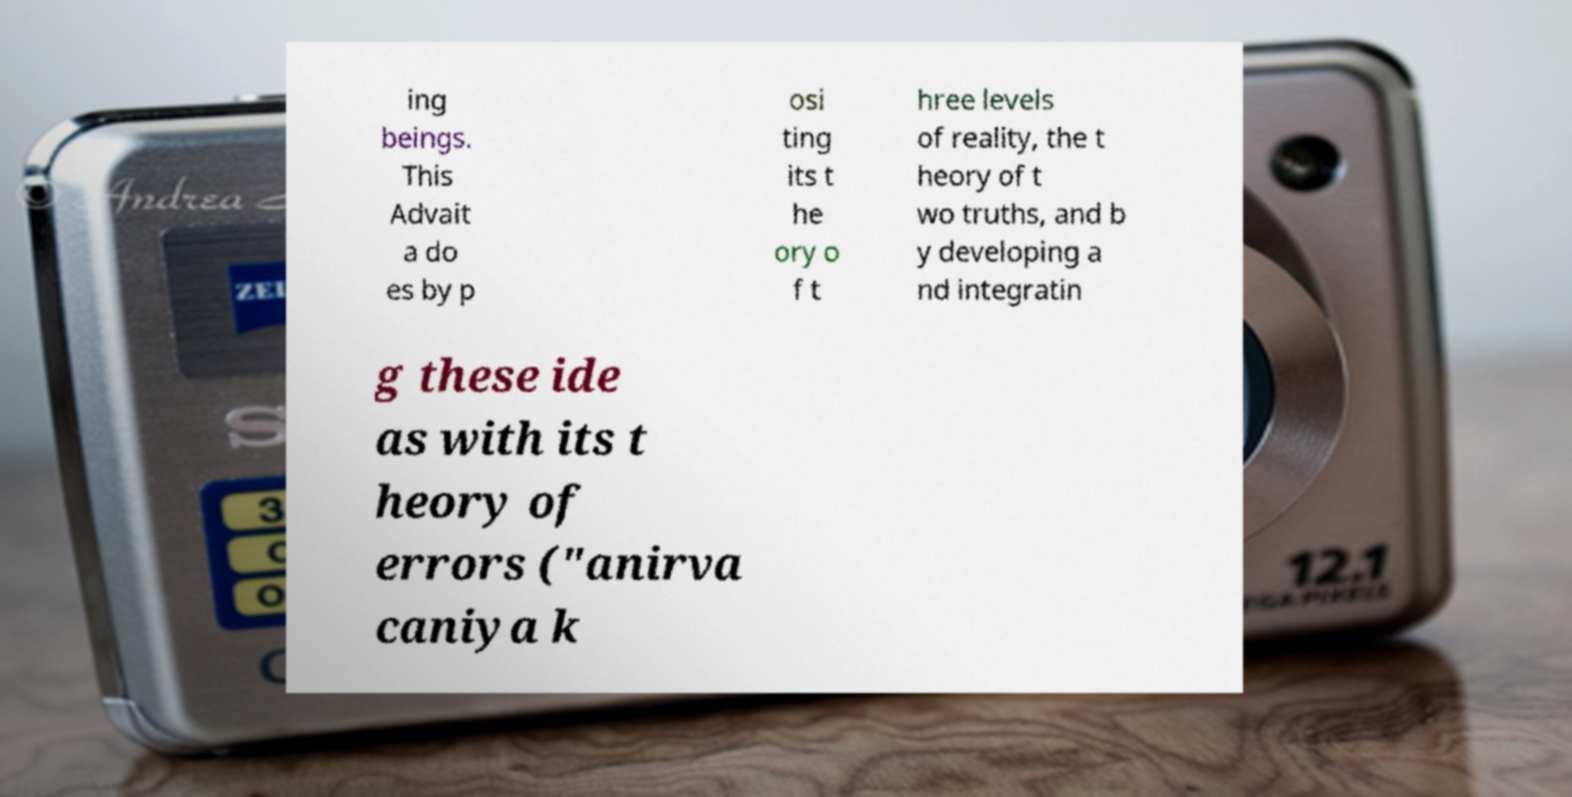Please read and relay the text visible in this image. What does it say? ing beings. This Advait a do es by p osi ting its t he ory o f t hree levels of reality, the t heory of t wo truths, and b y developing a nd integratin g these ide as with its t heory of errors ("anirva caniya k 